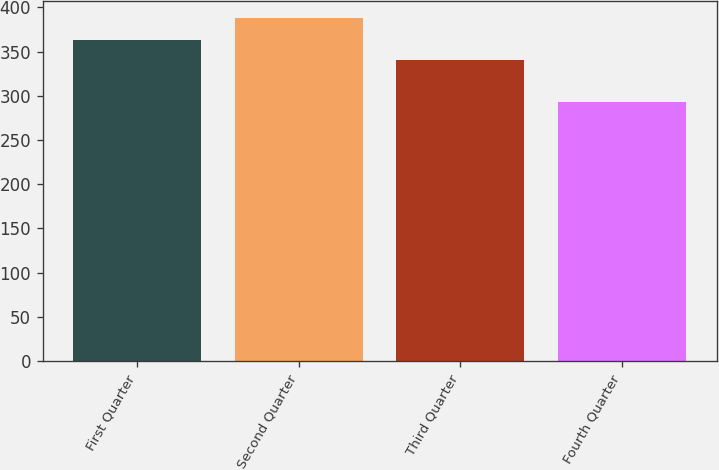Convert chart. <chart><loc_0><loc_0><loc_500><loc_500><bar_chart><fcel>First Quarter<fcel>Second Quarter<fcel>Third Quarter<fcel>Fourth Quarter<nl><fcel>362.8<fcel>388.01<fcel>340.51<fcel>292.89<nl></chart> 